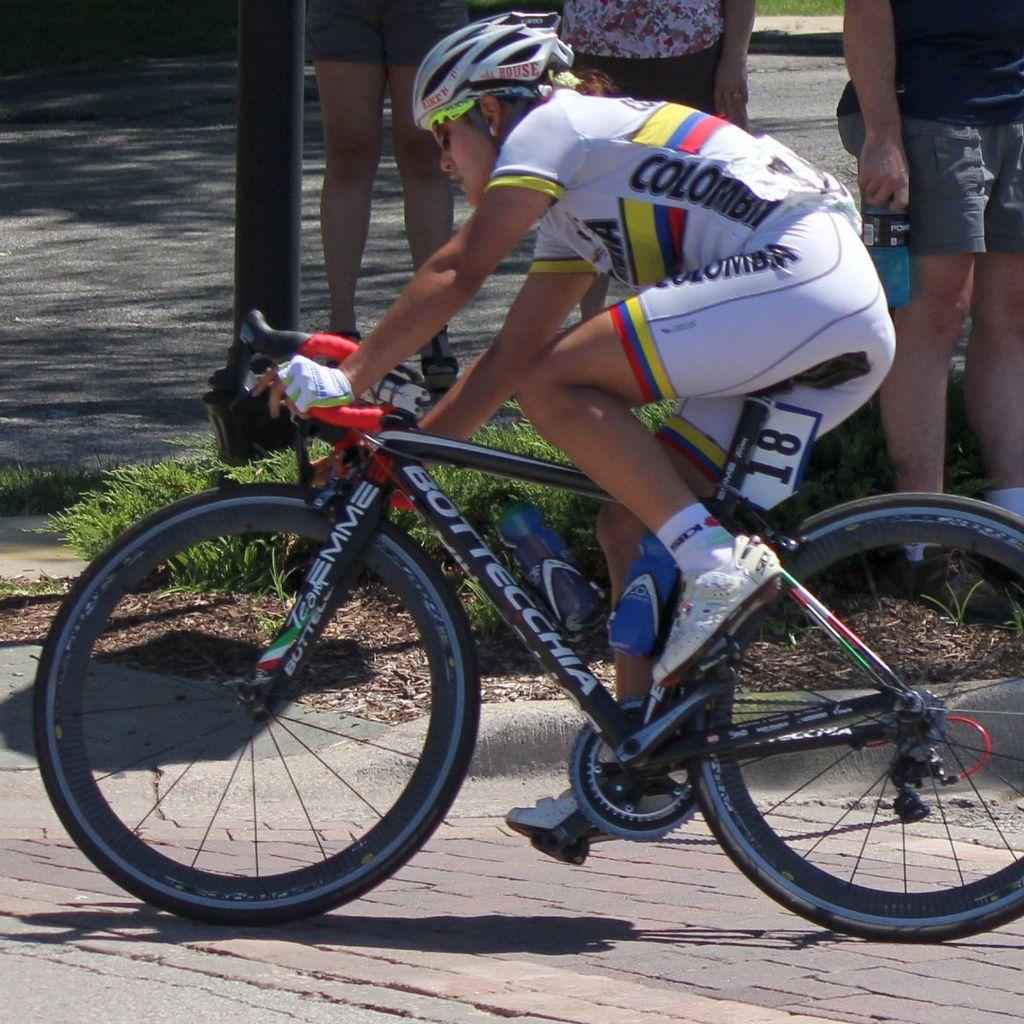What is the main subject of the image? The main subject of the image is a person riding a bicycle. Where is the person riding the bicycle? The person is on the road. What safety precaution is the person taking while riding the bicycle? The person is wearing a helmet. What can be seen in the background of the image? There are people standing on the grass in the background. How many boys are washing the pollution off the bicycle in the image? There are no boys washing any pollution off the bicycle in the image. 